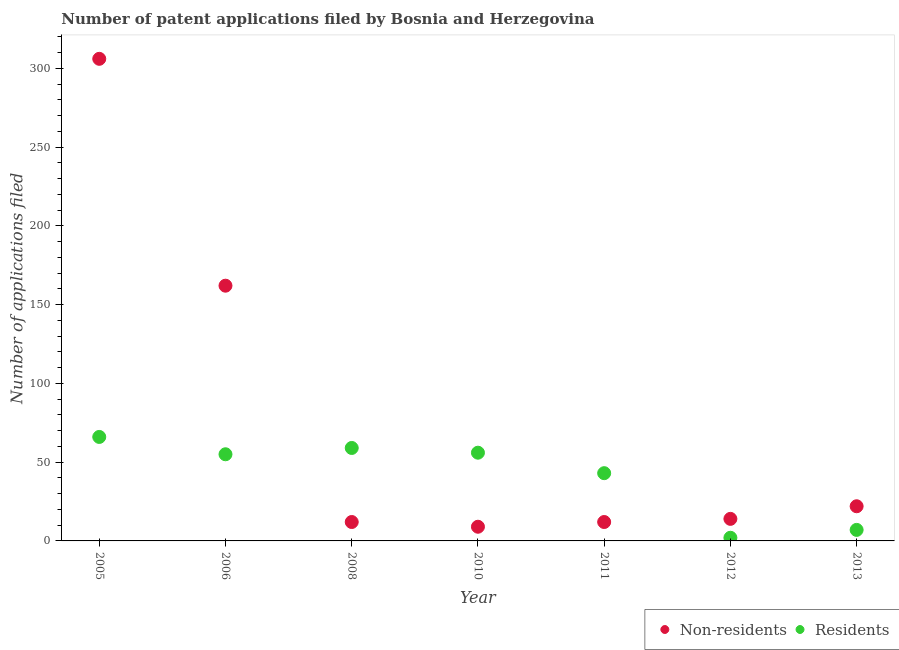Is the number of dotlines equal to the number of legend labels?
Offer a very short reply. Yes. What is the number of patent applications by non residents in 2006?
Provide a short and direct response. 162. Across all years, what is the maximum number of patent applications by residents?
Offer a terse response. 66. Across all years, what is the minimum number of patent applications by residents?
Offer a terse response. 2. In which year was the number of patent applications by residents maximum?
Offer a very short reply. 2005. In which year was the number of patent applications by residents minimum?
Keep it short and to the point. 2012. What is the total number of patent applications by residents in the graph?
Keep it short and to the point. 288. What is the difference between the number of patent applications by non residents in 2006 and that in 2008?
Offer a very short reply. 150. What is the difference between the number of patent applications by non residents in 2012 and the number of patent applications by residents in 2008?
Your answer should be compact. -45. What is the average number of patent applications by non residents per year?
Ensure brevity in your answer.  76.71. In the year 2012, what is the difference between the number of patent applications by non residents and number of patent applications by residents?
Your answer should be compact. 12. In how many years, is the number of patent applications by residents greater than 270?
Ensure brevity in your answer.  0. What is the ratio of the number of patent applications by residents in 2006 to that in 2011?
Keep it short and to the point. 1.28. Is the number of patent applications by non residents in 2010 less than that in 2011?
Offer a terse response. Yes. What is the difference between the highest and the second highest number of patent applications by residents?
Your answer should be compact. 7. What is the difference between the highest and the lowest number of patent applications by non residents?
Offer a terse response. 297. Is the sum of the number of patent applications by non residents in 2011 and 2012 greater than the maximum number of patent applications by residents across all years?
Make the answer very short. No. Does the number of patent applications by residents monotonically increase over the years?
Keep it short and to the point. No. How many dotlines are there?
Give a very brief answer. 2. How many years are there in the graph?
Offer a very short reply. 7. What is the difference between two consecutive major ticks on the Y-axis?
Keep it short and to the point. 50. Are the values on the major ticks of Y-axis written in scientific E-notation?
Your answer should be compact. No. Does the graph contain grids?
Your answer should be very brief. No. What is the title of the graph?
Keep it short and to the point. Number of patent applications filed by Bosnia and Herzegovina. What is the label or title of the X-axis?
Your answer should be compact. Year. What is the label or title of the Y-axis?
Provide a short and direct response. Number of applications filed. What is the Number of applications filed of Non-residents in 2005?
Provide a succinct answer. 306. What is the Number of applications filed in Non-residents in 2006?
Your answer should be very brief. 162. What is the Number of applications filed in Residents in 2006?
Your answer should be very brief. 55. What is the Number of applications filed of Non-residents in 2008?
Make the answer very short. 12. What is the Number of applications filed in Residents in 2008?
Give a very brief answer. 59. What is the Number of applications filed of Non-residents in 2010?
Make the answer very short. 9. What is the Number of applications filed of Non-residents in 2011?
Provide a succinct answer. 12. What is the Number of applications filed of Residents in 2012?
Your answer should be very brief. 2. What is the Number of applications filed of Non-residents in 2013?
Your response must be concise. 22. What is the Number of applications filed of Residents in 2013?
Give a very brief answer. 7. Across all years, what is the maximum Number of applications filed of Non-residents?
Your answer should be very brief. 306. What is the total Number of applications filed of Non-residents in the graph?
Your answer should be very brief. 537. What is the total Number of applications filed in Residents in the graph?
Provide a succinct answer. 288. What is the difference between the Number of applications filed in Non-residents in 2005 and that in 2006?
Your response must be concise. 144. What is the difference between the Number of applications filed in Residents in 2005 and that in 2006?
Offer a terse response. 11. What is the difference between the Number of applications filed of Non-residents in 2005 and that in 2008?
Your answer should be very brief. 294. What is the difference between the Number of applications filed in Non-residents in 2005 and that in 2010?
Provide a succinct answer. 297. What is the difference between the Number of applications filed of Non-residents in 2005 and that in 2011?
Offer a very short reply. 294. What is the difference between the Number of applications filed of Residents in 2005 and that in 2011?
Your answer should be very brief. 23. What is the difference between the Number of applications filed in Non-residents in 2005 and that in 2012?
Give a very brief answer. 292. What is the difference between the Number of applications filed of Residents in 2005 and that in 2012?
Your answer should be compact. 64. What is the difference between the Number of applications filed of Non-residents in 2005 and that in 2013?
Make the answer very short. 284. What is the difference between the Number of applications filed of Residents in 2005 and that in 2013?
Offer a terse response. 59. What is the difference between the Number of applications filed in Non-residents in 2006 and that in 2008?
Offer a terse response. 150. What is the difference between the Number of applications filed of Non-residents in 2006 and that in 2010?
Provide a short and direct response. 153. What is the difference between the Number of applications filed of Non-residents in 2006 and that in 2011?
Make the answer very short. 150. What is the difference between the Number of applications filed of Residents in 2006 and that in 2011?
Offer a very short reply. 12. What is the difference between the Number of applications filed of Non-residents in 2006 and that in 2012?
Ensure brevity in your answer.  148. What is the difference between the Number of applications filed in Non-residents in 2006 and that in 2013?
Keep it short and to the point. 140. What is the difference between the Number of applications filed in Non-residents in 2008 and that in 2010?
Provide a succinct answer. 3. What is the difference between the Number of applications filed in Non-residents in 2008 and that in 2011?
Your answer should be very brief. 0. What is the difference between the Number of applications filed of Residents in 2008 and that in 2012?
Offer a very short reply. 57. What is the difference between the Number of applications filed in Non-residents in 2008 and that in 2013?
Your answer should be very brief. -10. What is the difference between the Number of applications filed of Residents in 2008 and that in 2013?
Your response must be concise. 52. What is the difference between the Number of applications filed in Non-residents in 2010 and that in 2011?
Make the answer very short. -3. What is the difference between the Number of applications filed of Residents in 2010 and that in 2011?
Provide a short and direct response. 13. What is the difference between the Number of applications filed of Non-residents in 2010 and that in 2012?
Make the answer very short. -5. What is the difference between the Number of applications filed in Residents in 2010 and that in 2013?
Your answer should be compact. 49. What is the difference between the Number of applications filed of Residents in 2011 and that in 2012?
Ensure brevity in your answer.  41. What is the difference between the Number of applications filed of Residents in 2011 and that in 2013?
Your response must be concise. 36. What is the difference between the Number of applications filed of Non-residents in 2012 and that in 2013?
Keep it short and to the point. -8. What is the difference between the Number of applications filed of Residents in 2012 and that in 2013?
Provide a succinct answer. -5. What is the difference between the Number of applications filed of Non-residents in 2005 and the Number of applications filed of Residents in 2006?
Ensure brevity in your answer.  251. What is the difference between the Number of applications filed of Non-residents in 2005 and the Number of applications filed of Residents in 2008?
Provide a succinct answer. 247. What is the difference between the Number of applications filed of Non-residents in 2005 and the Number of applications filed of Residents in 2010?
Keep it short and to the point. 250. What is the difference between the Number of applications filed in Non-residents in 2005 and the Number of applications filed in Residents in 2011?
Your response must be concise. 263. What is the difference between the Number of applications filed in Non-residents in 2005 and the Number of applications filed in Residents in 2012?
Ensure brevity in your answer.  304. What is the difference between the Number of applications filed of Non-residents in 2005 and the Number of applications filed of Residents in 2013?
Make the answer very short. 299. What is the difference between the Number of applications filed in Non-residents in 2006 and the Number of applications filed in Residents in 2008?
Your response must be concise. 103. What is the difference between the Number of applications filed of Non-residents in 2006 and the Number of applications filed of Residents in 2010?
Your answer should be very brief. 106. What is the difference between the Number of applications filed in Non-residents in 2006 and the Number of applications filed in Residents in 2011?
Ensure brevity in your answer.  119. What is the difference between the Number of applications filed in Non-residents in 2006 and the Number of applications filed in Residents in 2012?
Provide a succinct answer. 160. What is the difference between the Number of applications filed in Non-residents in 2006 and the Number of applications filed in Residents in 2013?
Ensure brevity in your answer.  155. What is the difference between the Number of applications filed of Non-residents in 2008 and the Number of applications filed of Residents in 2010?
Your answer should be very brief. -44. What is the difference between the Number of applications filed of Non-residents in 2008 and the Number of applications filed of Residents in 2011?
Your answer should be compact. -31. What is the difference between the Number of applications filed in Non-residents in 2008 and the Number of applications filed in Residents in 2013?
Provide a succinct answer. 5. What is the difference between the Number of applications filed of Non-residents in 2010 and the Number of applications filed of Residents in 2011?
Make the answer very short. -34. What is the difference between the Number of applications filed of Non-residents in 2010 and the Number of applications filed of Residents in 2013?
Your answer should be compact. 2. What is the difference between the Number of applications filed in Non-residents in 2011 and the Number of applications filed in Residents in 2012?
Your response must be concise. 10. What is the difference between the Number of applications filed in Non-residents in 2011 and the Number of applications filed in Residents in 2013?
Provide a succinct answer. 5. What is the average Number of applications filed in Non-residents per year?
Your answer should be very brief. 76.71. What is the average Number of applications filed in Residents per year?
Make the answer very short. 41.14. In the year 2005, what is the difference between the Number of applications filed in Non-residents and Number of applications filed in Residents?
Give a very brief answer. 240. In the year 2006, what is the difference between the Number of applications filed in Non-residents and Number of applications filed in Residents?
Provide a succinct answer. 107. In the year 2008, what is the difference between the Number of applications filed in Non-residents and Number of applications filed in Residents?
Offer a very short reply. -47. In the year 2010, what is the difference between the Number of applications filed in Non-residents and Number of applications filed in Residents?
Ensure brevity in your answer.  -47. In the year 2011, what is the difference between the Number of applications filed of Non-residents and Number of applications filed of Residents?
Your answer should be very brief. -31. What is the ratio of the Number of applications filed in Non-residents in 2005 to that in 2006?
Give a very brief answer. 1.89. What is the ratio of the Number of applications filed of Residents in 2005 to that in 2006?
Offer a very short reply. 1.2. What is the ratio of the Number of applications filed in Non-residents in 2005 to that in 2008?
Provide a succinct answer. 25.5. What is the ratio of the Number of applications filed in Residents in 2005 to that in 2008?
Make the answer very short. 1.12. What is the ratio of the Number of applications filed of Residents in 2005 to that in 2010?
Make the answer very short. 1.18. What is the ratio of the Number of applications filed in Residents in 2005 to that in 2011?
Your response must be concise. 1.53. What is the ratio of the Number of applications filed in Non-residents in 2005 to that in 2012?
Give a very brief answer. 21.86. What is the ratio of the Number of applications filed in Non-residents in 2005 to that in 2013?
Your answer should be very brief. 13.91. What is the ratio of the Number of applications filed in Residents in 2005 to that in 2013?
Offer a terse response. 9.43. What is the ratio of the Number of applications filed of Residents in 2006 to that in 2008?
Keep it short and to the point. 0.93. What is the ratio of the Number of applications filed of Non-residents in 2006 to that in 2010?
Give a very brief answer. 18. What is the ratio of the Number of applications filed in Residents in 2006 to that in 2010?
Your answer should be compact. 0.98. What is the ratio of the Number of applications filed in Residents in 2006 to that in 2011?
Offer a very short reply. 1.28. What is the ratio of the Number of applications filed of Non-residents in 2006 to that in 2012?
Keep it short and to the point. 11.57. What is the ratio of the Number of applications filed of Non-residents in 2006 to that in 2013?
Your answer should be compact. 7.36. What is the ratio of the Number of applications filed in Residents in 2006 to that in 2013?
Offer a terse response. 7.86. What is the ratio of the Number of applications filed of Non-residents in 2008 to that in 2010?
Make the answer very short. 1.33. What is the ratio of the Number of applications filed of Residents in 2008 to that in 2010?
Give a very brief answer. 1.05. What is the ratio of the Number of applications filed of Non-residents in 2008 to that in 2011?
Offer a very short reply. 1. What is the ratio of the Number of applications filed of Residents in 2008 to that in 2011?
Give a very brief answer. 1.37. What is the ratio of the Number of applications filed of Non-residents in 2008 to that in 2012?
Keep it short and to the point. 0.86. What is the ratio of the Number of applications filed of Residents in 2008 to that in 2012?
Ensure brevity in your answer.  29.5. What is the ratio of the Number of applications filed in Non-residents in 2008 to that in 2013?
Make the answer very short. 0.55. What is the ratio of the Number of applications filed of Residents in 2008 to that in 2013?
Give a very brief answer. 8.43. What is the ratio of the Number of applications filed of Non-residents in 2010 to that in 2011?
Ensure brevity in your answer.  0.75. What is the ratio of the Number of applications filed in Residents in 2010 to that in 2011?
Your answer should be very brief. 1.3. What is the ratio of the Number of applications filed of Non-residents in 2010 to that in 2012?
Your answer should be compact. 0.64. What is the ratio of the Number of applications filed of Non-residents in 2010 to that in 2013?
Make the answer very short. 0.41. What is the ratio of the Number of applications filed of Residents in 2010 to that in 2013?
Make the answer very short. 8. What is the ratio of the Number of applications filed in Non-residents in 2011 to that in 2012?
Provide a short and direct response. 0.86. What is the ratio of the Number of applications filed of Non-residents in 2011 to that in 2013?
Make the answer very short. 0.55. What is the ratio of the Number of applications filed of Residents in 2011 to that in 2013?
Your answer should be very brief. 6.14. What is the ratio of the Number of applications filed in Non-residents in 2012 to that in 2013?
Keep it short and to the point. 0.64. What is the ratio of the Number of applications filed in Residents in 2012 to that in 2013?
Your answer should be compact. 0.29. What is the difference between the highest and the second highest Number of applications filed in Non-residents?
Keep it short and to the point. 144. What is the difference between the highest and the second highest Number of applications filed in Residents?
Ensure brevity in your answer.  7. What is the difference between the highest and the lowest Number of applications filed in Non-residents?
Your answer should be very brief. 297. 